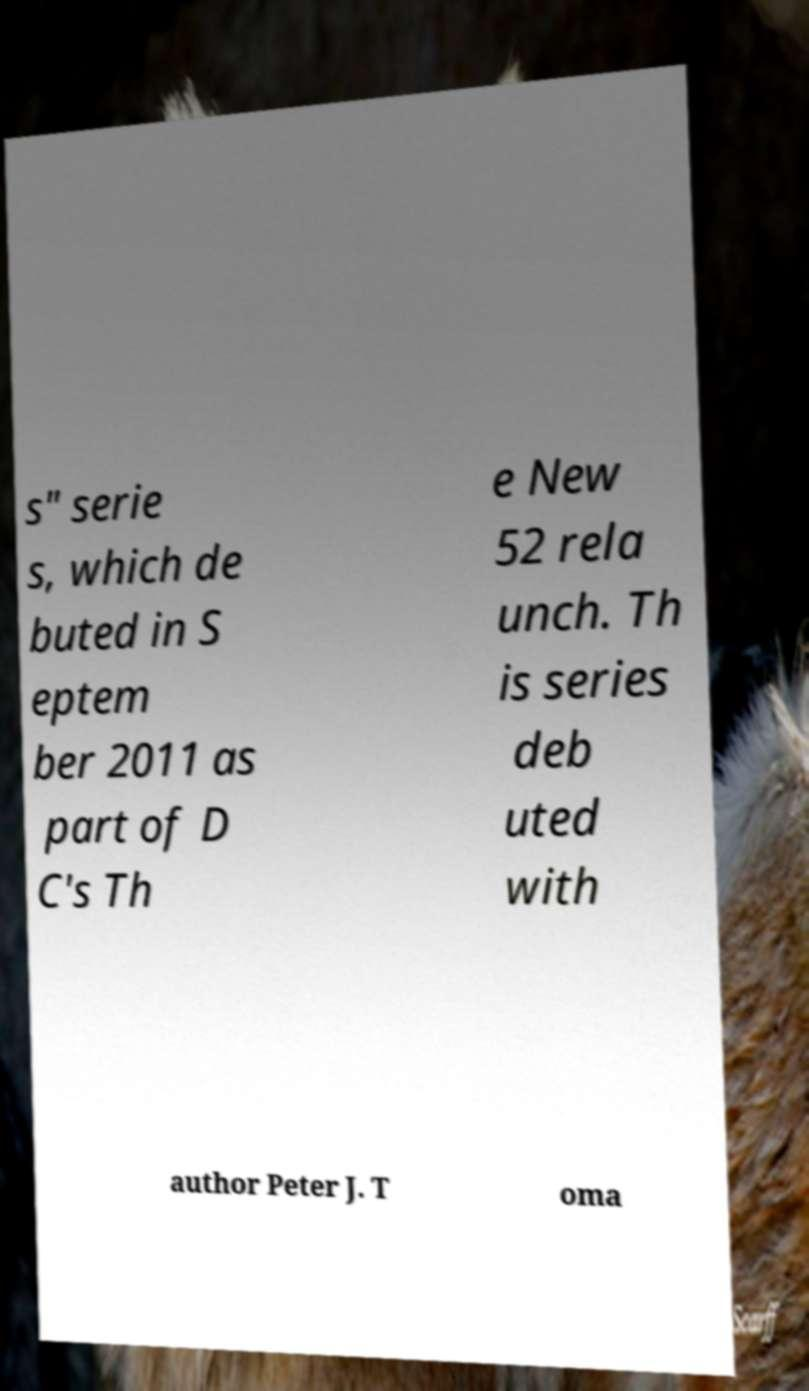Can you accurately transcribe the text from the provided image for me? s" serie s, which de buted in S eptem ber 2011 as part of D C's Th e New 52 rela unch. Th is series deb uted with author Peter J. T oma 